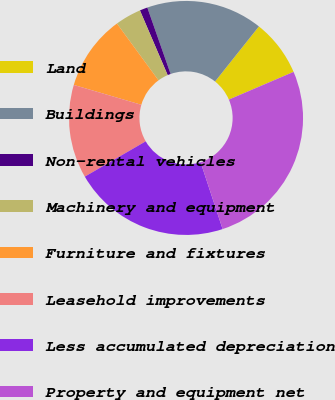Convert chart. <chart><loc_0><loc_0><loc_500><loc_500><pie_chart><fcel>Land<fcel>Buildings<fcel>Non-rental vehicles<fcel>Machinery and equipment<fcel>Furniture and fixtures<fcel>Leasehold improvements<fcel>Less accumulated depreciation<fcel>Property and equipment net<nl><fcel>7.86%<fcel>16.07%<fcel>1.08%<fcel>3.61%<fcel>10.39%<fcel>12.92%<fcel>21.7%<fcel>26.38%<nl></chart> 